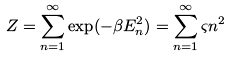<formula> <loc_0><loc_0><loc_500><loc_500>Z = \sum _ { n = 1 } ^ { \infty } \exp ( - \beta E _ { n } ^ { 2 } ) = \sum _ { n = 1 } ^ { \infty } \varsigma n ^ { 2 }</formula> 